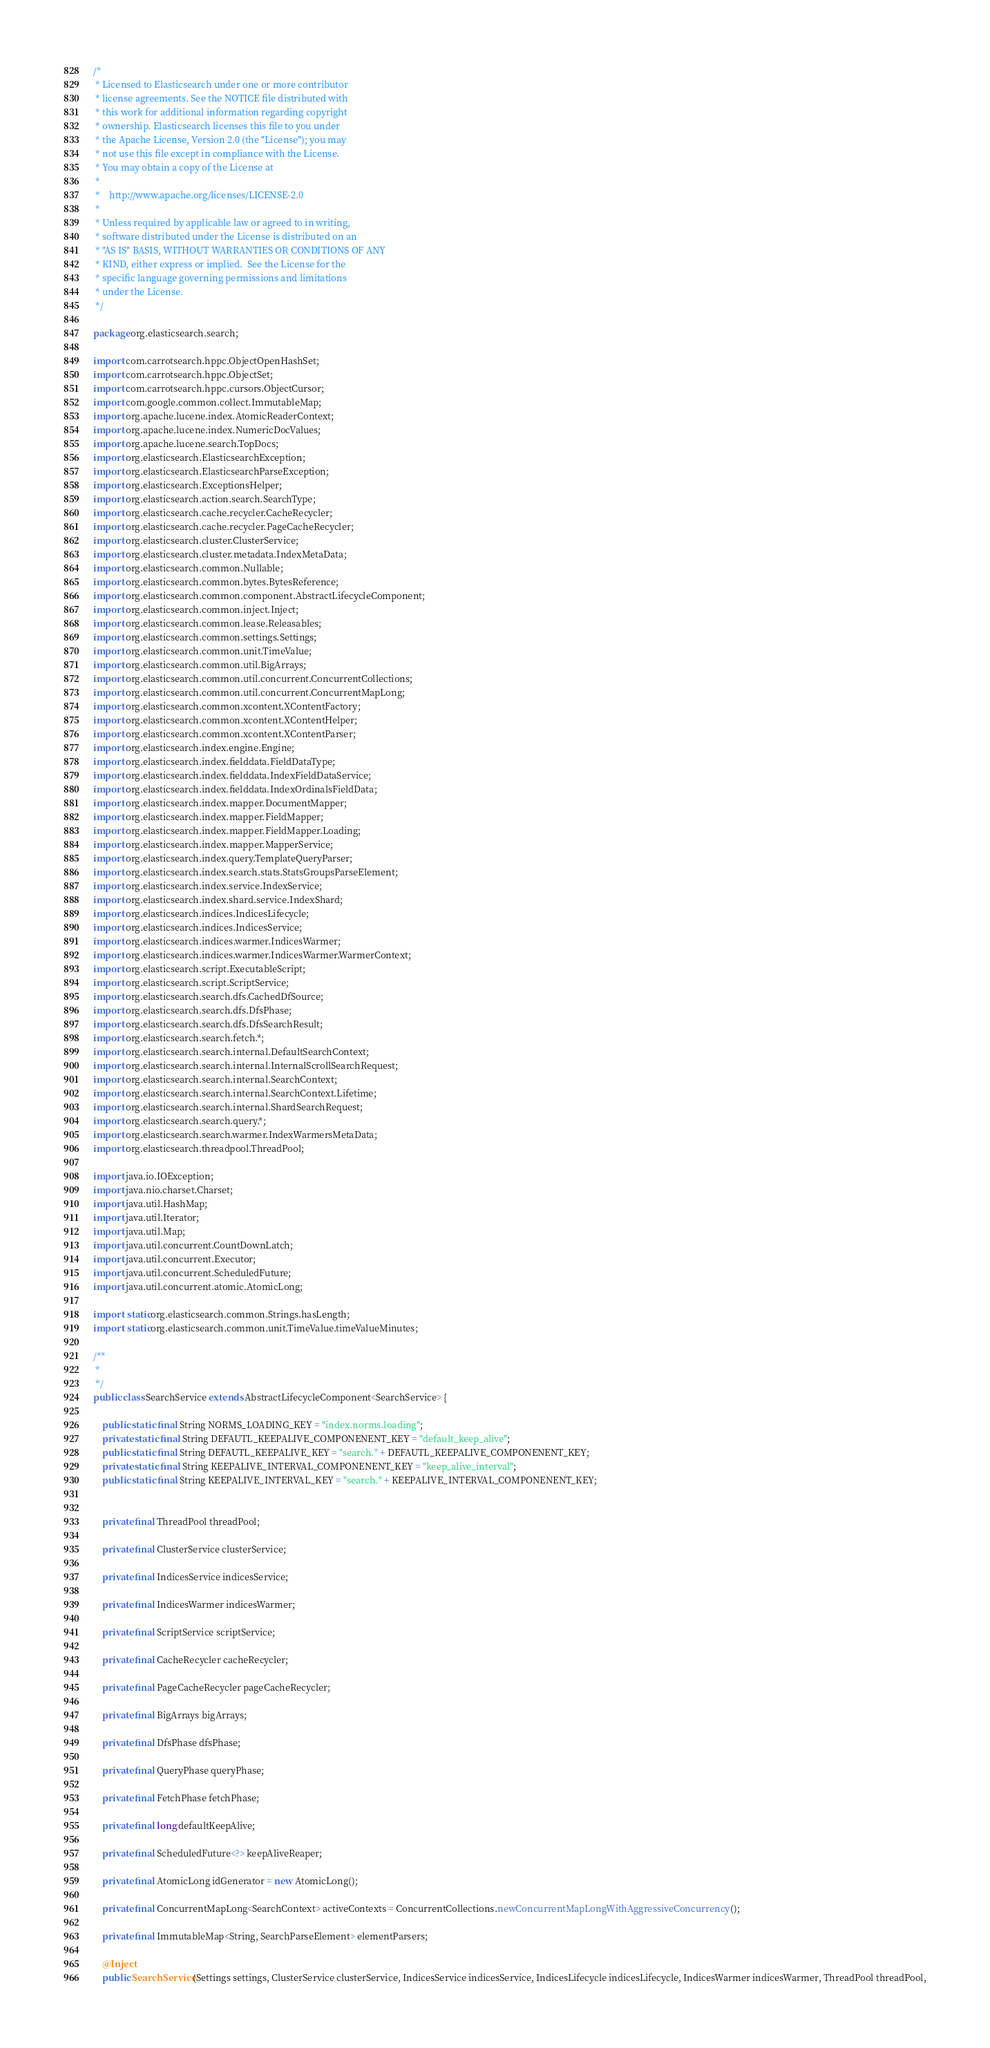Convert code to text. <code><loc_0><loc_0><loc_500><loc_500><_Java_>/*
 * Licensed to Elasticsearch under one or more contributor
 * license agreements. See the NOTICE file distributed with
 * this work for additional information regarding copyright
 * ownership. Elasticsearch licenses this file to you under
 * the Apache License, Version 2.0 (the "License"); you may
 * not use this file except in compliance with the License.
 * You may obtain a copy of the License at
 *
 *    http://www.apache.org/licenses/LICENSE-2.0
 *
 * Unless required by applicable law or agreed to in writing,
 * software distributed under the License is distributed on an
 * "AS IS" BASIS, WITHOUT WARRANTIES OR CONDITIONS OF ANY
 * KIND, either express or implied.  See the License for the
 * specific language governing permissions and limitations
 * under the License.
 */

package org.elasticsearch.search;

import com.carrotsearch.hppc.ObjectOpenHashSet;
import com.carrotsearch.hppc.ObjectSet;
import com.carrotsearch.hppc.cursors.ObjectCursor;
import com.google.common.collect.ImmutableMap;
import org.apache.lucene.index.AtomicReaderContext;
import org.apache.lucene.index.NumericDocValues;
import org.apache.lucene.search.TopDocs;
import org.elasticsearch.ElasticsearchException;
import org.elasticsearch.ElasticsearchParseException;
import org.elasticsearch.ExceptionsHelper;
import org.elasticsearch.action.search.SearchType;
import org.elasticsearch.cache.recycler.CacheRecycler;
import org.elasticsearch.cache.recycler.PageCacheRecycler;
import org.elasticsearch.cluster.ClusterService;
import org.elasticsearch.cluster.metadata.IndexMetaData;
import org.elasticsearch.common.Nullable;
import org.elasticsearch.common.bytes.BytesReference;
import org.elasticsearch.common.component.AbstractLifecycleComponent;
import org.elasticsearch.common.inject.Inject;
import org.elasticsearch.common.lease.Releasables;
import org.elasticsearch.common.settings.Settings;
import org.elasticsearch.common.unit.TimeValue;
import org.elasticsearch.common.util.BigArrays;
import org.elasticsearch.common.util.concurrent.ConcurrentCollections;
import org.elasticsearch.common.util.concurrent.ConcurrentMapLong;
import org.elasticsearch.common.xcontent.XContentFactory;
import org.elasticsearch.common.xcontent.XContentHelper;
import org.elasticsearch.common.xcontent.XContentParser;
import org.elasticsearch.index.engine.Engine;
import org.elasticsearch.index.fielddata.FieldDataType;
import org.elasticsearch.index.fielddata.IndexFieldDataService;
import org.elasticsearch.index.fielddata.IndexOrdinalsFieldData;
import org.elasticsearch.index.mapper.DocumentMapper;
import org.elasticsearch.index.mapper.FieldMapper;
import org.elasticsearch.index.mapper.FieldMapper.Loading;
import org.elasticsearch.index.mapper.MapperService;
import org.elasticsearch.index.query.TemplateQueryParser;
import org.elasticsearch.index.search.stats.StatsGroupsParseElement;
import org.elasticsearch.index.service.IndexService;
import org.elasticsearch.index.shard.service.IndexShard;
import org.elasticsearch.indices.IndicesLifecycle;
import org.elasticsearch.indices.IndicesService;
import org.elasticsearch.indices.warmer.IndicesWarmer;
import org.elasticsearch.indices.warmer.IndicesWarmer.WarmerContext;
import org.elasticsearch.script.ExecutableScript;
import org.elasticsearch.script.ScriptService;
import org.elasticsearch.search.dfs.CachedDfSource;
import org.elasticsearch.search.dfs.DfsPhase;
import org.elasticsearch.search.dfs.DfsSearchResult;
import org.elasticsearch.search.fetch.*;
import org.elasticsearch.search.internal.DefaultSearchContext;
import org.elasticsearch.search.internal.InternalScrollSearchRequest;
import org.elasticsearch.search.internal.SearchContext;
import org.elasticsearch.search.internal.SearchContext.Lifetime;
import org.elasticsearch.search.internal.ShardSearchRequest;
import org.elasticsearch.search.query.*;
import org.elasticsearch.search.warmer.IndexWarmersMetaData;
import org.elasticsearch.threadpool.ThreadPool;

import java.io.IOException;
import java.nio.charset.Charset;
import java.util.HashMap;
import java.util.Iterator;
import java.util.Map;
import java.util.concurrent.CountDownLatch;
import java.util.concurrent.Executor;
import java.util.concurrent.ScheduledFuture;
import java.util.concurrent.atomic.AtomicLong;

import static org.elasticsearch.common.Strings.hasLength;
import static org.elasticsearch.common.unit.TimeValue.timeValueMinutes;

/**
 *
 */
public class SearchService extends AbstractLifecycleComponent<SearchService> {

    public static final String NORMS_LOADING_KEY = "index.norms.loading";
    private static final String DEFAUTL_KEEPALIVE_COMPONENENT_KEY = "default_keep_alive";
    public static final String DEFAUTL_KEEPALIVE_KEY = "search." + DEFAUTL_KEEPALIVE_COMPONENENT_KEY;
    private static final String KEEPALIVE_INTERVAL_COMPONENENT_KEY = "keep_alive_interval";
    public static final String KEEPALIVE_INTERVAL_KEY = "search." + KEEPALIVE_INTERVAL_COMPONENENT_KEY;


    private final ThreadPool threadPool;

    private final ClusterService clusterService;

    private final IndicesService indicesService;

    private final IndicesWarmer indicesWarmer;

    private final ScriptService scriptService;

    private final CacheRecycler cacheRecycler;

    private final PageCacheRecycler pageCacheRecycler;

    private final BigArrays bigArrays;

    private final DfsPhase dfsPhase;

    private final QueryPhase queryPhase;

    private final FetchPhase fetchPhase;

    private final long defaultKeepAlive;

    private final ScheduledFuture<?> keepAliveReaper;

    private final AtomicLong idGenerator = new AtomicLong();

    private final ConcurrentMapLong<SearchContext> activeContexts = ConcurrentCollections.newConcurrentMapLongWithAggressiveConcurrency();

    private final ImmutableMap<String, SearchParseElement> elementParsers;

    @Inject
    public SearchService(Settings settings, ClusterService clusterService, IndicesService indicesService, IndicesLifecycle indicesLifecycle, IndicesWarmer indicesWarmer, ThreadPool threadPool,</code> 